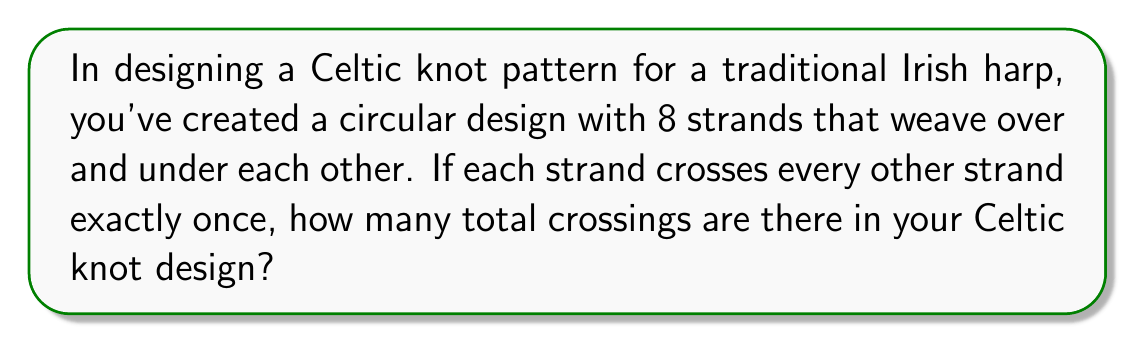Give your solution to this math problem. Let's approach this step-by-step:

1) In a Celtic knot where each strand crosses every other strand once, we can use the formula for combinations to determine the number of crossings.

2) The formula for combinations is:

   $$C(n,r) = \frac{n!}{r!(n-r)!}$$

   where $n$ is the total number of strands and $r$ is the number of strands involved in each crossing.

3) In this case:
   - $n = 8$ (total number of strands)
   - $r = 2$ (each crossing involves 2 strands)

4) Plugging these values into our formula:

   $$C(8,2) = \frac{8!}{2!(8-2)!} = \frac{8!}{2!(6)!}$$

5) Expanding this:
   
   $$\frac{8 * 7 * 6!}{2 * 1 * 6!}$$

6) The $6!$ cancels out in the numerator and denominator:

   $$\frac{8 * 7}{2 * 1} = \frac{56}{2} = 28$$

Therefore, there are 28 crossings in the Celtic knot design.
Answer: 28 crossings 